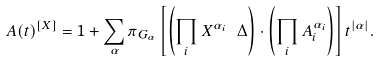<formula> <loc_0><loc_0><loc_500><loc_500>A ( t ) ^ { [ X ] } = 1 + \sum _ { \alpha } \pi _ { G _ { \alpha } } \left [ \left ( \prod _ { i } X ^ { \alpha _ { i } } \ \Delta \right ) \cdot \left ( \prod _ { i } A _ { i } ^ { \alpha _ { i } } \right ) \right ] t ^ { | \alpha | } .</formula> 